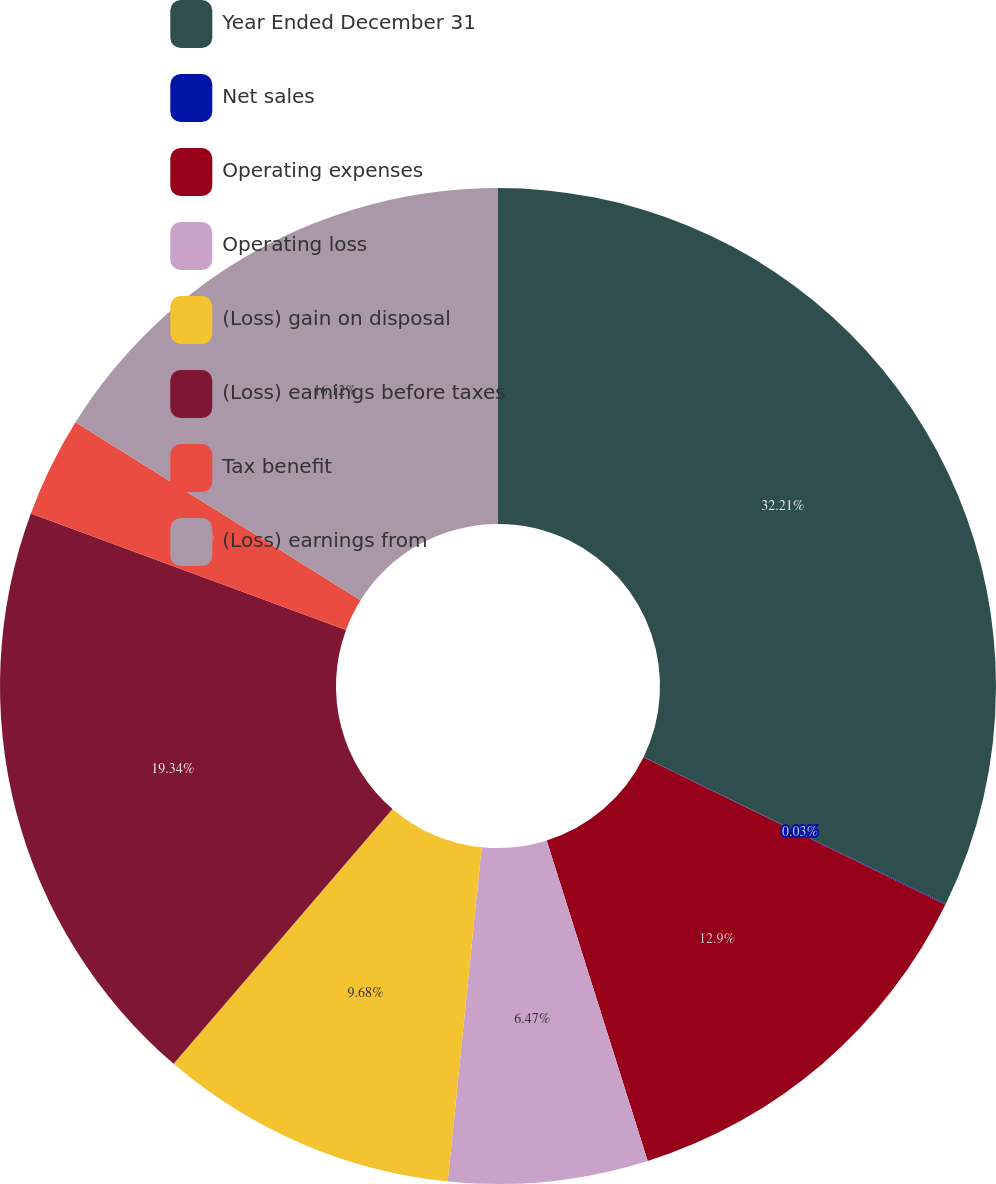Convert chart. <chart><loc_0><loc_0><loc_500><loc_500><pie_chart><fcel>Year Ended December 31<fcel>Net sales<fcel>Operating expenses<fcel>Operating loss<fcel>(Loss) gain on disposal<fcel>(Loss) earnings before taxes<fcel>Tax benefit<fcel>(Loss) earnings from<nl><fcel>32.21%<fcel>0.03%<fcel>12.9%<fcel>6.47%<fcel>9.68%<fcel>19.34%<fcel>3.25%<fcel>16.12%<nl></chart> 